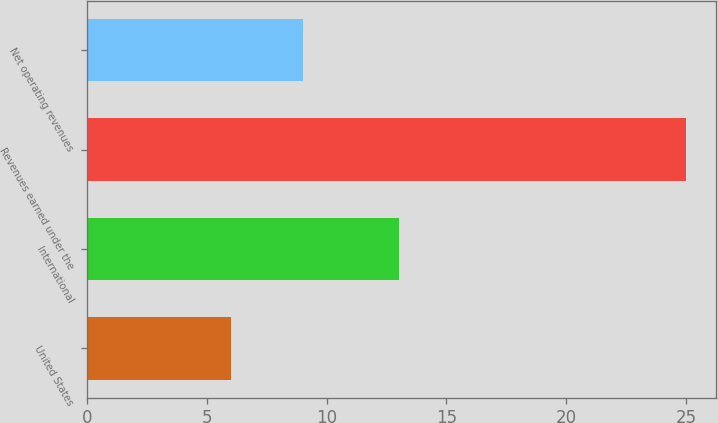Convert chart to OTSL. <chart><loc_0><loc_0><loc_500><loc_500><bar_chart><fcel>United States<fcel>International<fcel>Revenues earned under the<fcel>Net operating revenues<nl><fcel>6<fcel>13<fcel>25<fcel>9<nl></chart> 